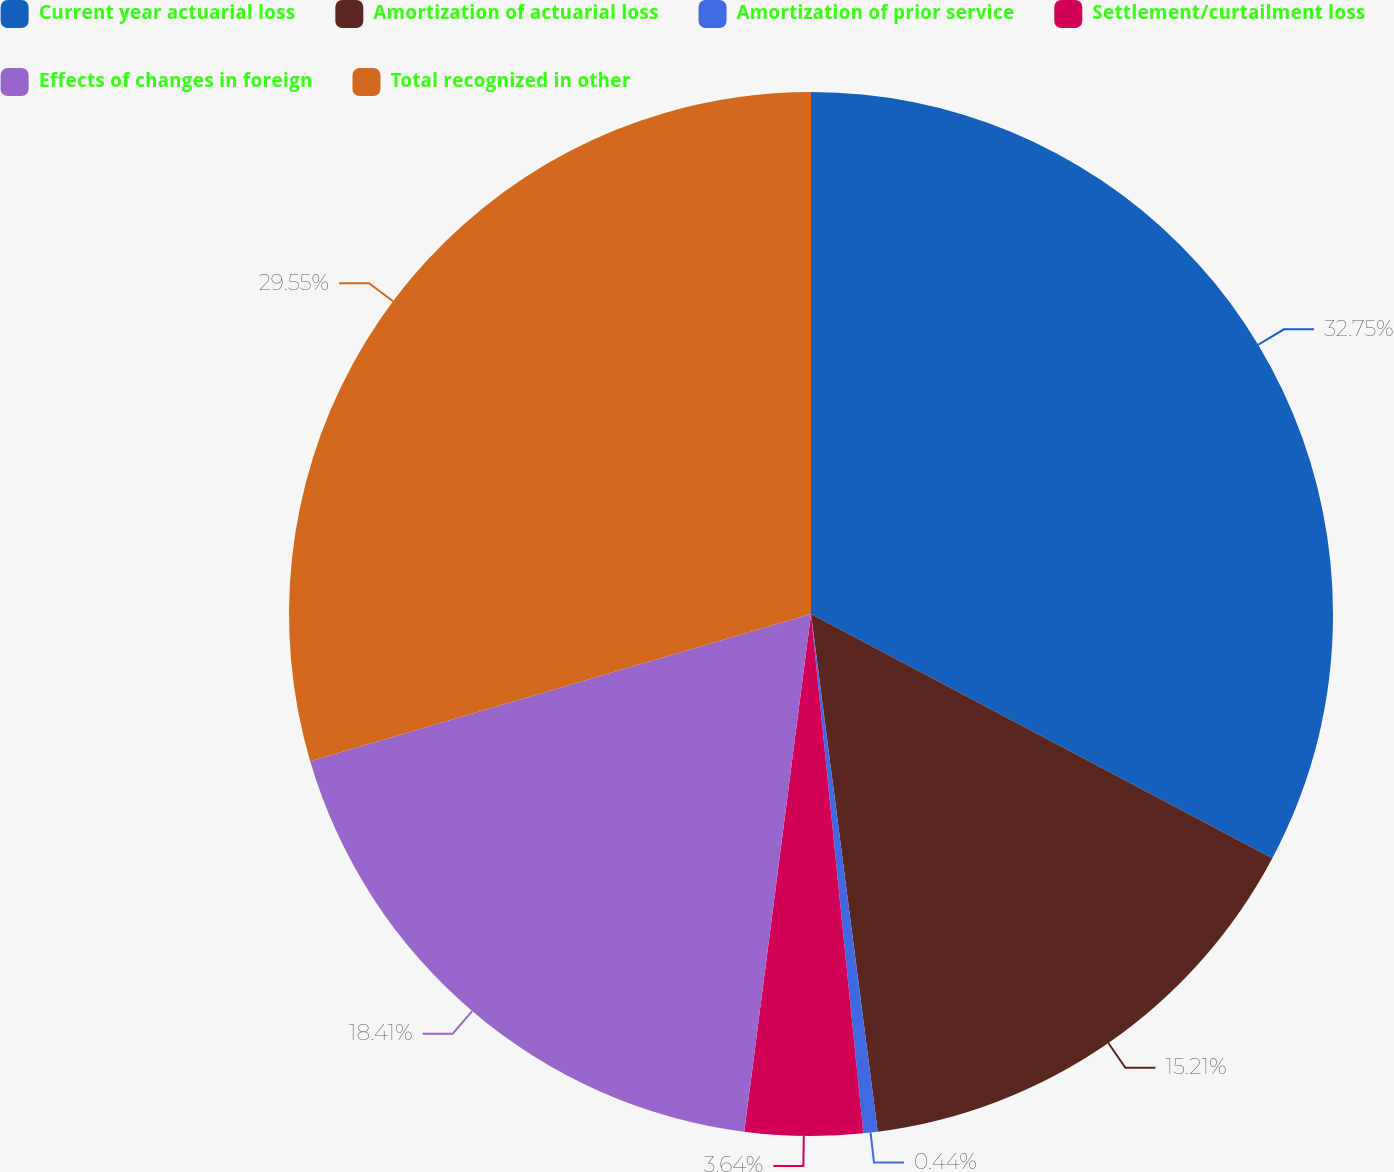<chart> <loc_0><loc_0><loc_500><loc_500><pie_chart><fcel>Current year actuarial loss<fcel>Amortization of actuarial loss<fcel>Amortization of prior service<fcel>Settlement/curtailment loss<fcel>Effects of changes in foreign<fcel>Total recognized in other<nl><fcel>32.75%<fcel>15.21%<fcel>0.44%<fcel>3.64%<fcel>18.41%<fcel>29.55%<nl></chart> 